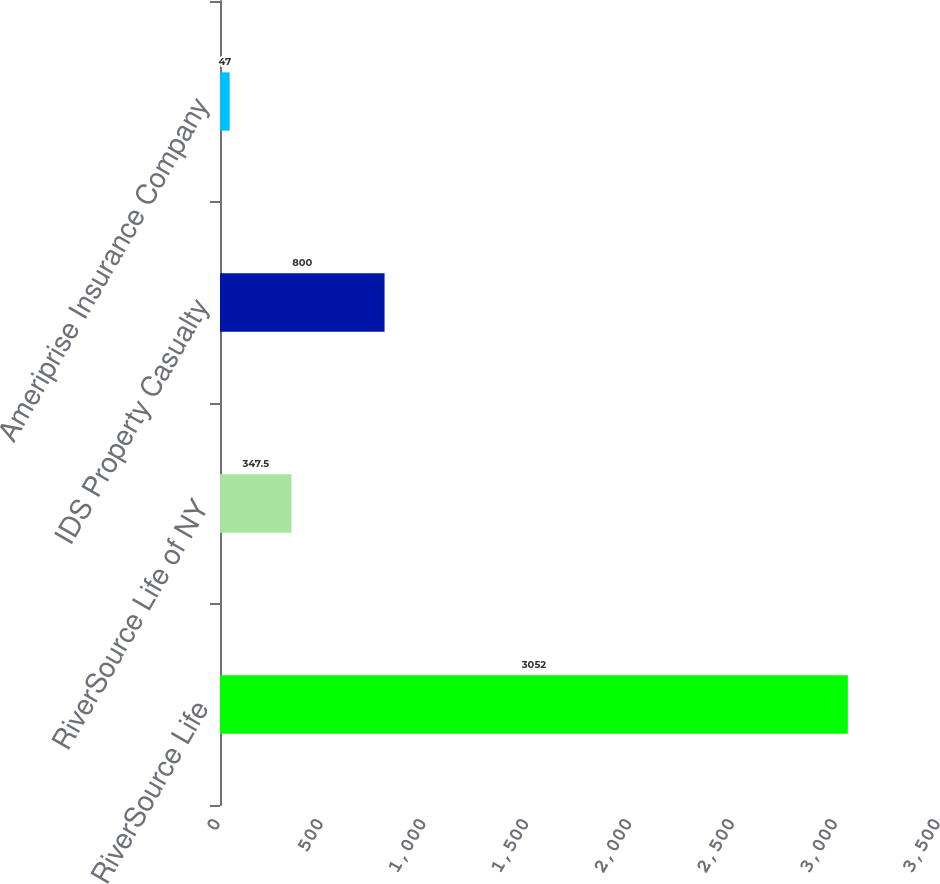<chart> <loc_0><loc_0><loc_500><loc_500><bar_chart><fcel>RiverSource Life<fcel>RiverSource Life of NY<fcel>IDS Property Casualty<fcel>Ameriprise Insurance Company<nl><fcel>3052<fcel>347.5<fcel>800<fcel>47<nl></chart> 